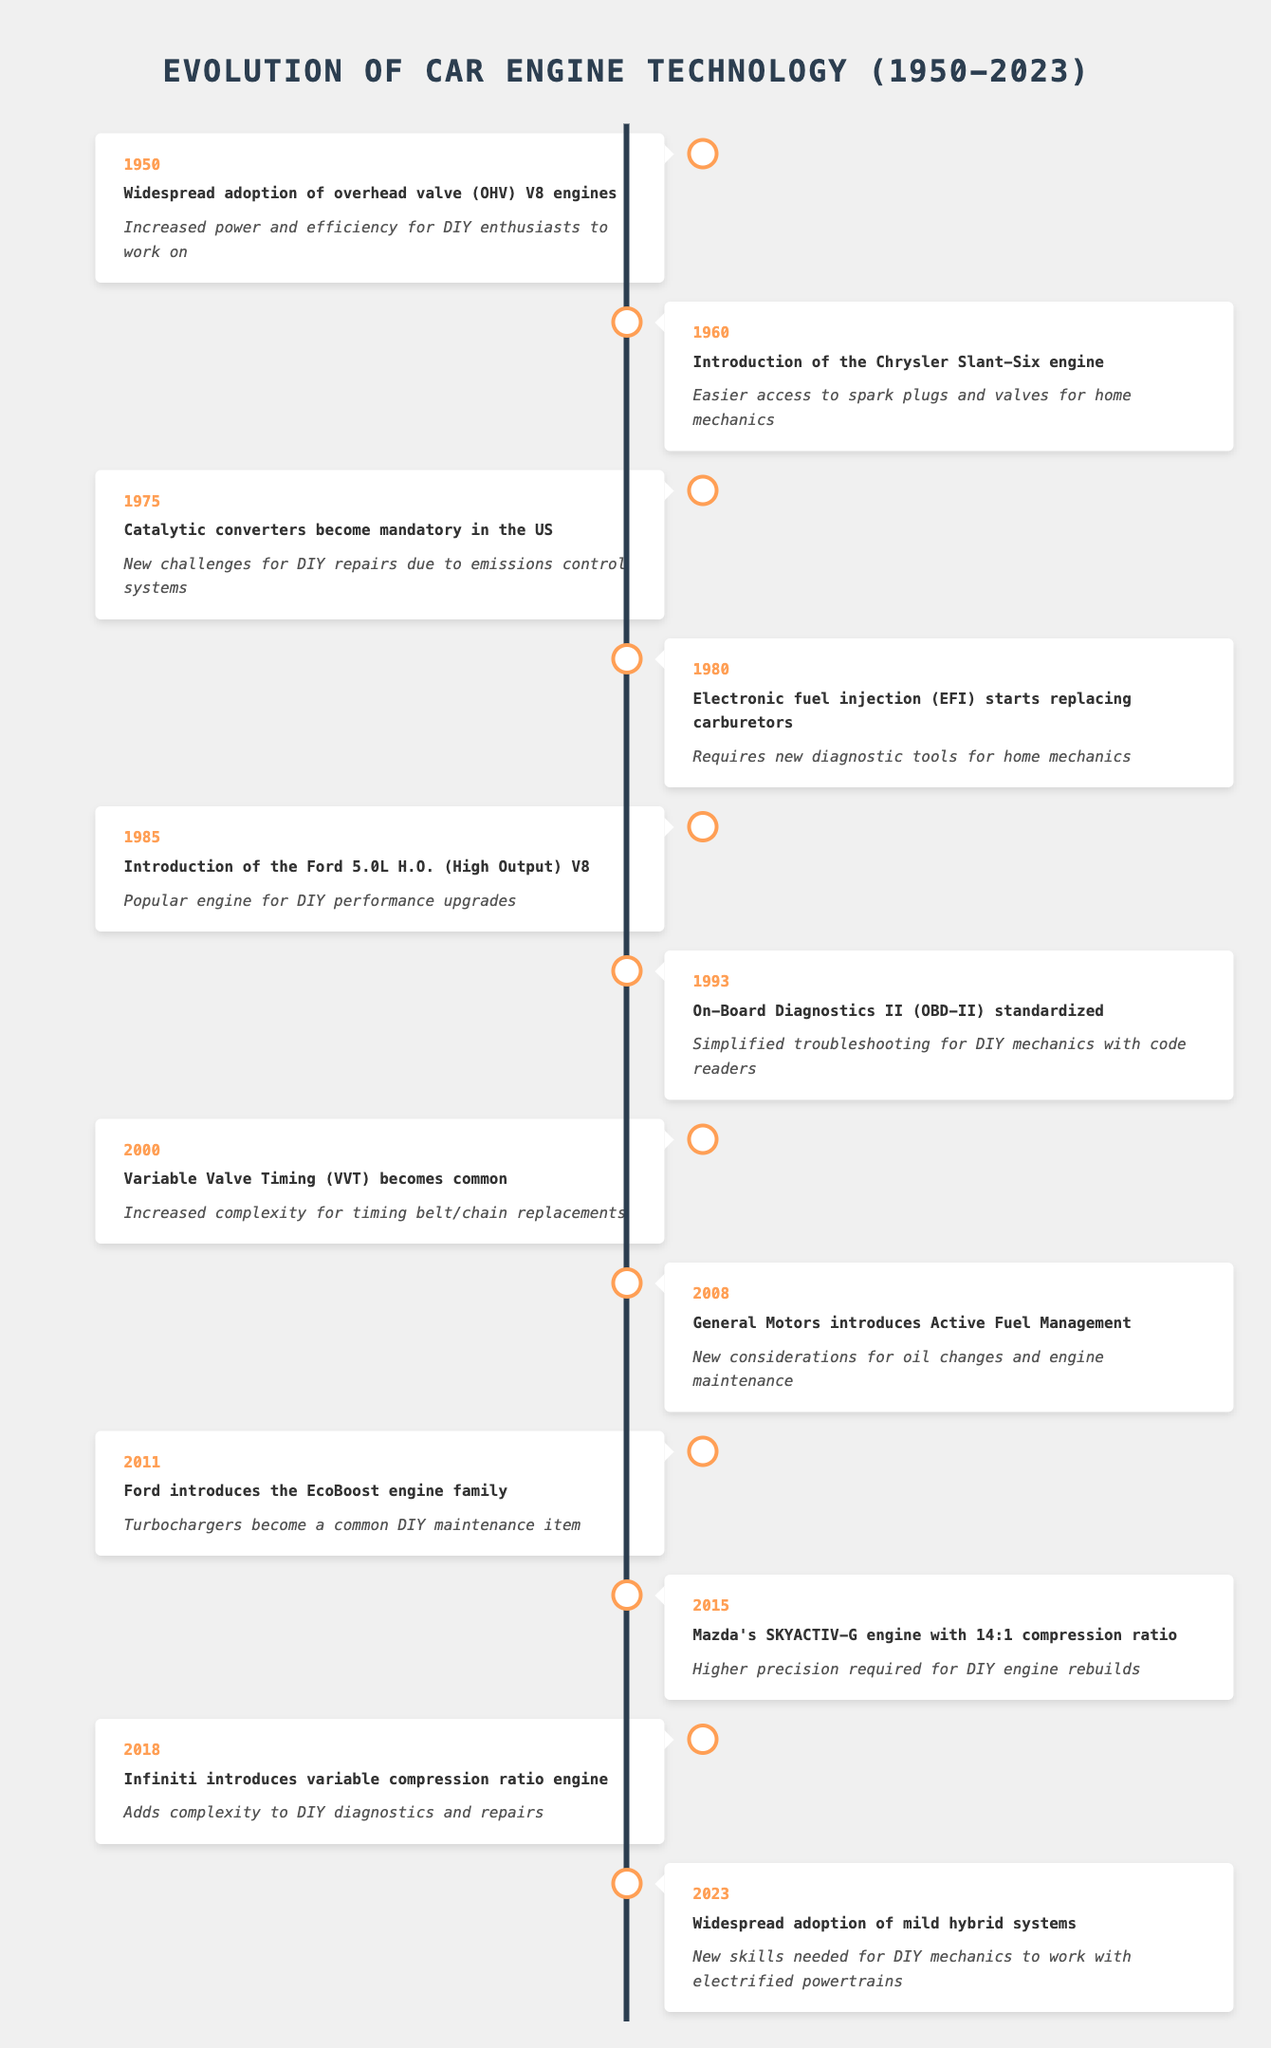What event occurred in 1980 regarding car engines? The event listed for the year 1980 in the table is the introduction of Electronic Fuel Injection (EFI) which started replacing carburetors.
Answer: Electronic fuel injection starts replacing carburetors What impact did the introduction of On-Board Diagnostics II have in 1993? The impact for the year 1993 indicates that On-Board Diagnostics II (OBD-II) standardized simplified troubleshooting for DIY mechanics with code readers.
Answer: Simplified troubleshooting for DIY mechanics Which engine introduced in 1985 is known for DIY performance upgrades? According to the table, the engine introduced in 1985 that is popular for DIY performance upgrades is the Ford 5.0L H.O. (High Output) V8.
Answer: Ford 5.0L H.O. (High Output) V8 How many years are between the introduction of the Chrysler Slant-Six engine and the introduction of Electronic Fuel Injection? The Chrysler Slant-Six engine was introduced in 1960, and EFI started replacing carburetors in 1980. The difference is 1980 - 1960 = 20 years.
Answer: 20 years Did the introduction of mild hybrid systems in 2023 add new skills needed for DIY mechanics? The impact of the event in 2023 indicates that new skills are indeed needed for DIY mechanics to work with electrified powertrains.
Answer: Yes Which event had a negative impact for DIY repairs due to emissions control systems, and what year did it occur? The event that had a negative impact for DIY repairs is when catalytic converters became mandatory in the US, and this occurred in 1975.
Answer: Catalytic converters become mandatory in 1975 What year did Variable Valve Timing (VVT) become common, and what was its impact? The year VVT became common is 2000, and the impact indicates that it increased complexity for timing belt/chain replacements.
Answer: 2000; increased complexity for timing belt/chain replacements Compare the complexity of DIY repairs before and after the introduction of the EcoBoost engine family in 2011. Before 2011, the table shows that there were already increasing complexities introduced with EFI and VVT, but the EcoBoost in 2011 added turbochargers as a common DIY maintenance item, suggesting an overall increase in complexity for repairs post-EcoBoost.
Answer: Increased complexity after 2011 